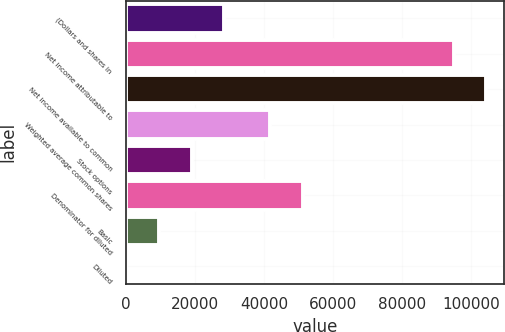Convert chart to OTSL. <chart><loc_0><loc_0><loc_500><loc_500><bar_chart><fcel>(Dollars and shares in<fcel>Net income attributable to<fcel>Net income available to common<fcel>Weighted average common shares<fcel>Stock options<fcel>Denominator for diluted<fcel>Basic<fcel>Diluted<nl><fcel>28486.9<fcel>94951<fcel>104446<fcel>41774<fcel>18992<fcel>51268.9<fcel>9497.12<fcel>2.24<nl></chart> 